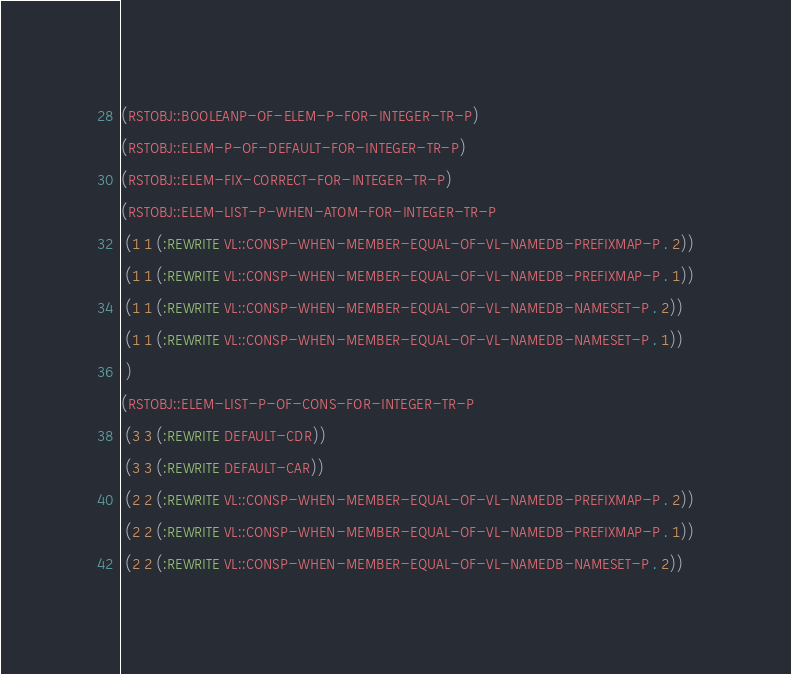Convert code to text. <code><loc_0><loc_0><loc_500><loc_500><_Lisp_>(RSTOBJ::BOOLEANP-OF-ELEM-P-FOR-INTEGER-TR-P)
(RSTOBJ::ELEM-P-OF-DEFAULT-FOR-INTEGER-TR-P)
(RSTOBJ::ELEM-FIX-CORRECT-FOR-INTEGER-TR-P)
(RSTOBJ::ELEM-LIST-P-WHEN-ATOM-FOR-INTEGER-TR-P
 (1 1 (:REWRITE VL::CONSP-WHEN-MEMBER-EQUAL-OF-VL-NAMEDB-PREFIXMAP-P . 2))
 (1 1 (:REWRITE VL::CONSP-WHEN-MEMBER-EQUAL-OF-VL-NAMEDB-PREFIXMAP-P . 1))
 (1 1 (:REWRITE VL::CONSP-WHEN-MEMBER-EQUAL-OF-VL-NAMEDB-NAMESET-P . 2))
 (1 1 (:REWRITE VL::CONSP-WHEN-MEMBER-EQUAL-OF-VL-NAMEDB-NAMESET-P . 1))
 )
(RSTOBJ::ELEM-LIST-P-OF-CONS-FOR-INTEGER-TR-P
 (3 3 (:REWRITE DEFAULT-CDR))
 (3 3 (:REWRITE DEFAULT-CAR))
 (2 2 (:REWRITE VL::CONSP-WHEN-MEMBER-EQUAL-OF-VL-NAMEDB-PREFIXMAP-P . 2))
 (2 2 (:REWRITE VL::CONSP-WHEN-MEMBER-EQUAL-OF-VL-NAMEDB-PREFIXMAP-P . 1))
 (2 2 (:REWRITE VL::CONSP-WHEN-MEMBER-EQUAL-OF-VL-NAMEDB-NAMESET-P . 2))</code> 